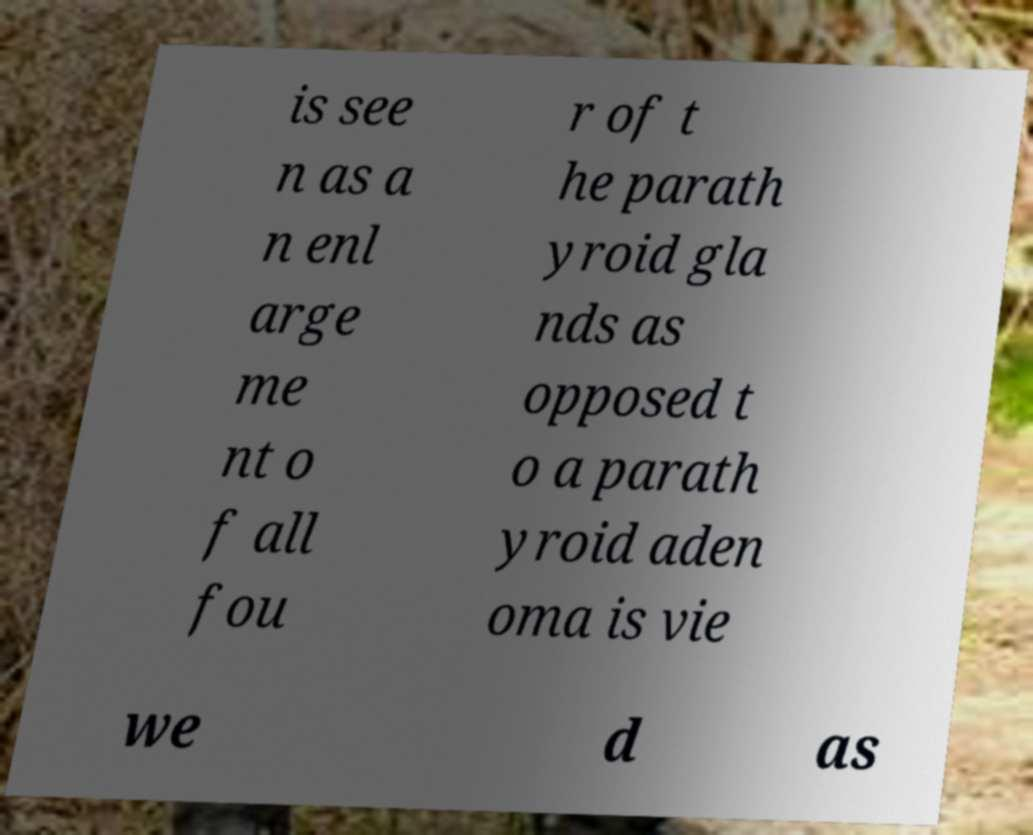Could you extract and type out the text from this image? is see n as a n enl arge me nt o f all fou r of t he parath yroid gla nds as opposed t o a parath yroid aden oma is vie we d as 